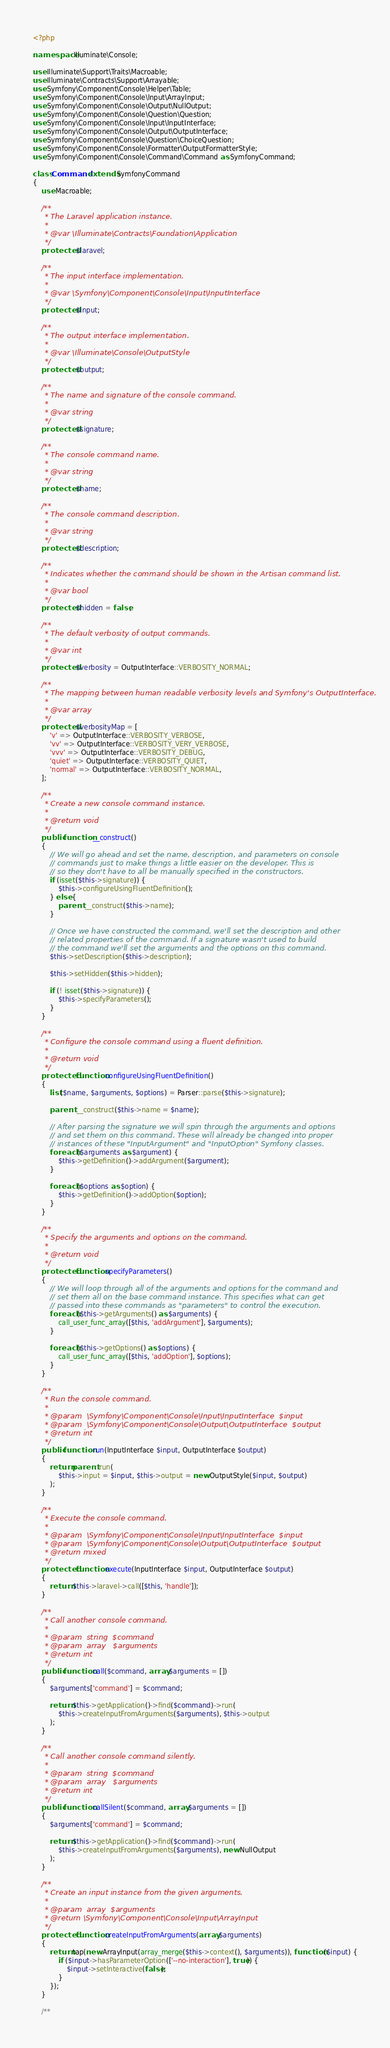<code> <loc_0><loc_0><loc_500><loc_500><_PHP_><?php

namespace Illuminate\Console;

use Illuminate\Support\Traits\Macroable;
use Illuminate\Contracts\Support\Arrayable;
use Symfony\Component\Console\Helper\Table;
use Symfony\Component\Console\Input\ArrayInput;
use Symfony\Component\Console\Output\NullOutput;
use Symfony\Component\Console\Question\Question;
use Symfony\Component\Console\Input\InputInterface;
use Symfony\Component\Console\Output\OutputInterface;
use Symfony\Component\Console\Question\ChoiceQuestion;
use Symfony\Component\Console\Formatter\OutputFormatterStyle;
use Symfony\Component\Console\Command\Command as SymfonyCommand;

class Command extends SymfonyCommand
{
    use Macroable;

    /**
     * The Laravel application instance.
     *
     * @var \Illuminate\Contracts\Foundation\Application
     */
    protected $laravel;

    /**
     * The input interface implementation.
     *
     * @var \Symfony\Component\Console\Input\InputInterface
     */
    protected $input;

    /**
     * The output interface implementation.
     *
     * @var \Illuminate\Console\OutputStyle
     */
    protected $output;

    /**
     * The name and signature of the console command.
     *
     * @var string
     */
    protected $signature;

    /**
     * The console command name.
     *
     * @var string
     */
    protected $name;

    /**
     * The console command description.
     *
     * @var string
     */
    protected $description;

    /**
     * Indicates whether the command should be shown in the Artisan command list.
     *
     * @var bool
     */
    protected $hidden = false;

    /**
     * The default verbosity of output commands.
     *
     * @var int
     */
    protected $verbosity = OutputInterface::VERBOSITY_NORMAL;

    /**
     * The mapping between human readable verbosity levels and Symfony's OutputInterface.
     *
     * @var array
     */
    protected $verbosityMap = [
        'v' => OutputInterface::VERBOSITY_VERBOSE,
        'vv' => OutputInterface::VERBOSITY_VERY_VERBOSE,
        'vvv' => OutputInterface::VERBOSITY_DEBUG,
        'quiet' => OutputInterface::VERBOSITY_QUIET,
        'normal' => OutputInterface::VERBOSITY_NORMAL,
    ];

    /**
     * Create a new console command instance.
     *
     * @return void
     */
    public function __construct()
    {
        // We will go ahead and set the name, description, and parameters on console
        // commands just to make things a little easier on the developer. This is
        // so they don't have to all be manually specified in the constructors.
        if (isset($this->signature)) {
            $this->configureUsingFluentDefinition();
        } else {
            parent::__construct($this->name);
        }

        // Once we have constructed the command, we'll set the description and other
        // related properties of the command. If a signature wasn't used to build
        // the command we'll set the arguments and the options on this command.
        $this->setDescription($this->description);

        $this->setHidden($this->hidden);

        if (! isset($this->signature)) {
            $this->specifyParameters();
        }
    }

    /**
     * Configure the console command using a fluent definition.
     *
     * @return void
     */
    protected function configureUsingFluentDefinition()
    {
        list($name, $arguments, $options) = Parser::parse($this->signature);

        parent::__construct($this->name = $name);

        // After parsing the signature we will spin through the arguments and options
        // and set them on this command. These will already be changed into proper
        // instances of these "InputArgument" and "InputOption" Symfony classes.
        foreach ($arguments as $argument) {
            $this->getDefinition()->addArgument($argument);
        }

        foreach ($options as $option) {
            $this->getDefinition()->addOption($option);
        }
    }

    /**
     * Specify the arguments and options on the command.
     *
     * @return void
     */
    protected function specifyParameters()
    {
        // We will loop through all of the arguments and options for the command and
        // set them all on the base command instance. This specifies what can get
        // passed into these commands as "parameters" to control the execution.
        foreach ($this->getArguments() as $arguments) {
            call_user_func_array([$this, 'addArgument'], $arguments);
        }

        foreach ($this->getOptions() as $options) {
            call_user_func_array([$this, 'addOption'], $options);
        }
    }

    /**
     * Run the console command.
     *
     * @param  \Symfony\Component\Console\Input\InputInterface  $input
     * @param  \Symfony\Component\Console\Output\OutputInterface  $output
     * @return int
     */
    public function run(InputInterface $input, OutputInterface $output)
    {
        return parent::run(
            $this->input = $input, $this->output = new OutputStyle($input, $output)
        );
    }

    /**
     * Execute the console command.
     *
     * @param  \Symfony\Component\Console\Input\InputInterface  $input
     * @param  \Symfony\Component\Console\Output\OutputInterface  $output
     * @return mixed
     */
    protected function execute(InputInterface $input, OutputInterface $output)
    {
        return $this->laravel->call([$this, 'handle']);
    }

    /**
     * Call another console command.
     *
     * @param  string  $command
     * @param  array   $arguments
     * @return int
     */
    public function call($command, array $arguments = [])
    {
        $arguments['command'] = $command;

        return $this->getApplication()->find($command)->run(
            $this->createInputFromArguments($arguments), $this->output
        );
    }

    /**
     * Call another console command silently.
     *
     * @param  string  $command
     * @param  array   $arguments
     * @return int
     */
    public function callSilent($command, array $arguments = [])
    {
        $arguments['command'] = $command;

        return $this->getApplication()->find($command)->run(
            $this->createInputFromArguments($arguments), new NullOutput
        );
    }

    /**
     * Create an input instance from the given arguments.
     *
     * @param  array  $arguments
     * @return \Symfony\Component\Console\Input\ArrayInput
     */
    protected function createInputFromArguments(array $arguments)
    {
        return tap(new ArrayInput(array_merge($this->context(), $arguments)), function ($input) {
            if ($input->hasParameterOption(['--no-interaction'], true)) {
                $input->setInteractive(false);
            }
        });
    }

    /**</code> 